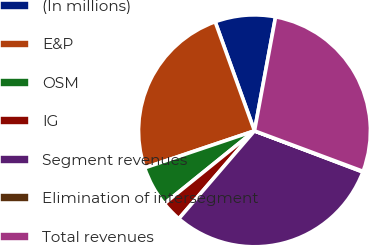Convert chart to OTSL. <chart><loc_0><loc_0><loc_500><loc_500><pie_chart><fcel>(In millions)<fcel>E&P<fcel>OSM<fcel>IG<fcel>Segment revenues<fcel>Elimination of intersegment<fcel>Total revenues<nl><fcel>8.42%<fcel>24.67%<fcel>5.64%<fcel>2.87%<fcel>30.54%<fcel>0.09%<fcel>27.77%<nl></chart> 